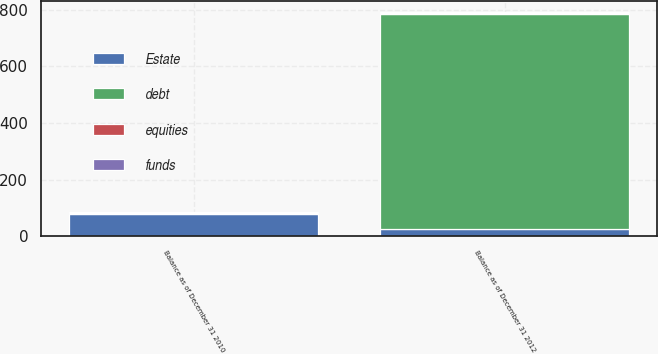Convert chart to OTSL. <chart><loc_0><loc_0><loc_500><loc_500><stacked_bar_chart><ecel><fcel>Balance as of December 31 2010<fcel>Balance as of December 31 2012<nl><fcel>equities<fcel>2<fcel>2<nl><fcel>funds<fcel>4<fcel>4<nl><fcel>Estate<fcel>78<fcel>28<nl><fcel>debt<fcel>4<fcel>758<nl></chart> 